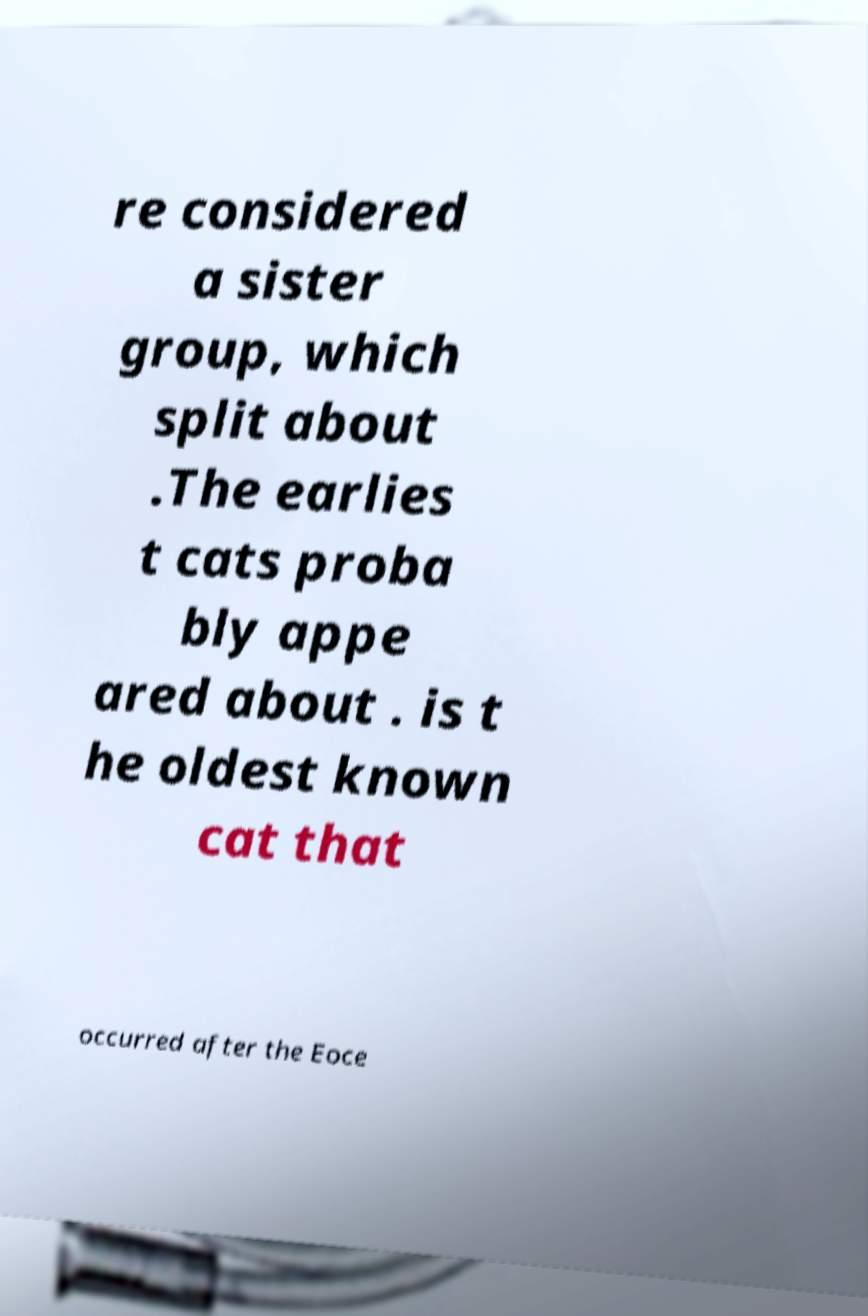For documentation purposes, I need the text within this image transcribed. Could you provide that? re considered a sister group, which split about .The earlies t cats proba bly appe ared about . is t he oldest known cat that occurred after the Eoce 